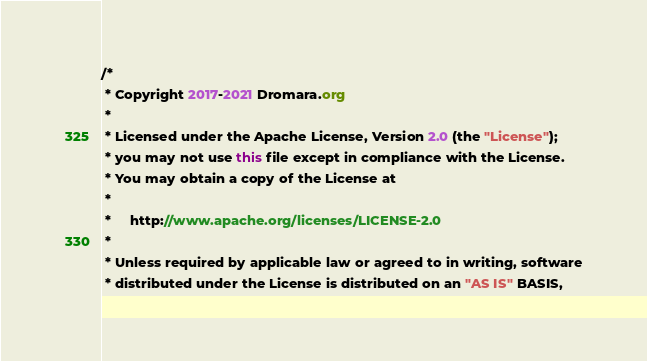Convert code to text. <code><loc_0><loc_0><loc_500><loc_500><_Java_>/*
 * Copyright 2017-2021 Dromara.org
 *
 * Licensed under the Apache License, Version 2.0 (the "License");
 * you may not use this file except in compliance with the License.
 * You may obtain a copy of the License at
 *
 *     http://www.apache.org/licenses/LICENSE-2.0
 *
 * Unless required by applicable law or agreed to in writing, software
 * distributed under the License is distributed on an "AS IS" BASIS,</code> 